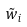<formula> <loc_0><loc_0><loc_500><loc_500>\tilde { w } _ { i }</formula> 